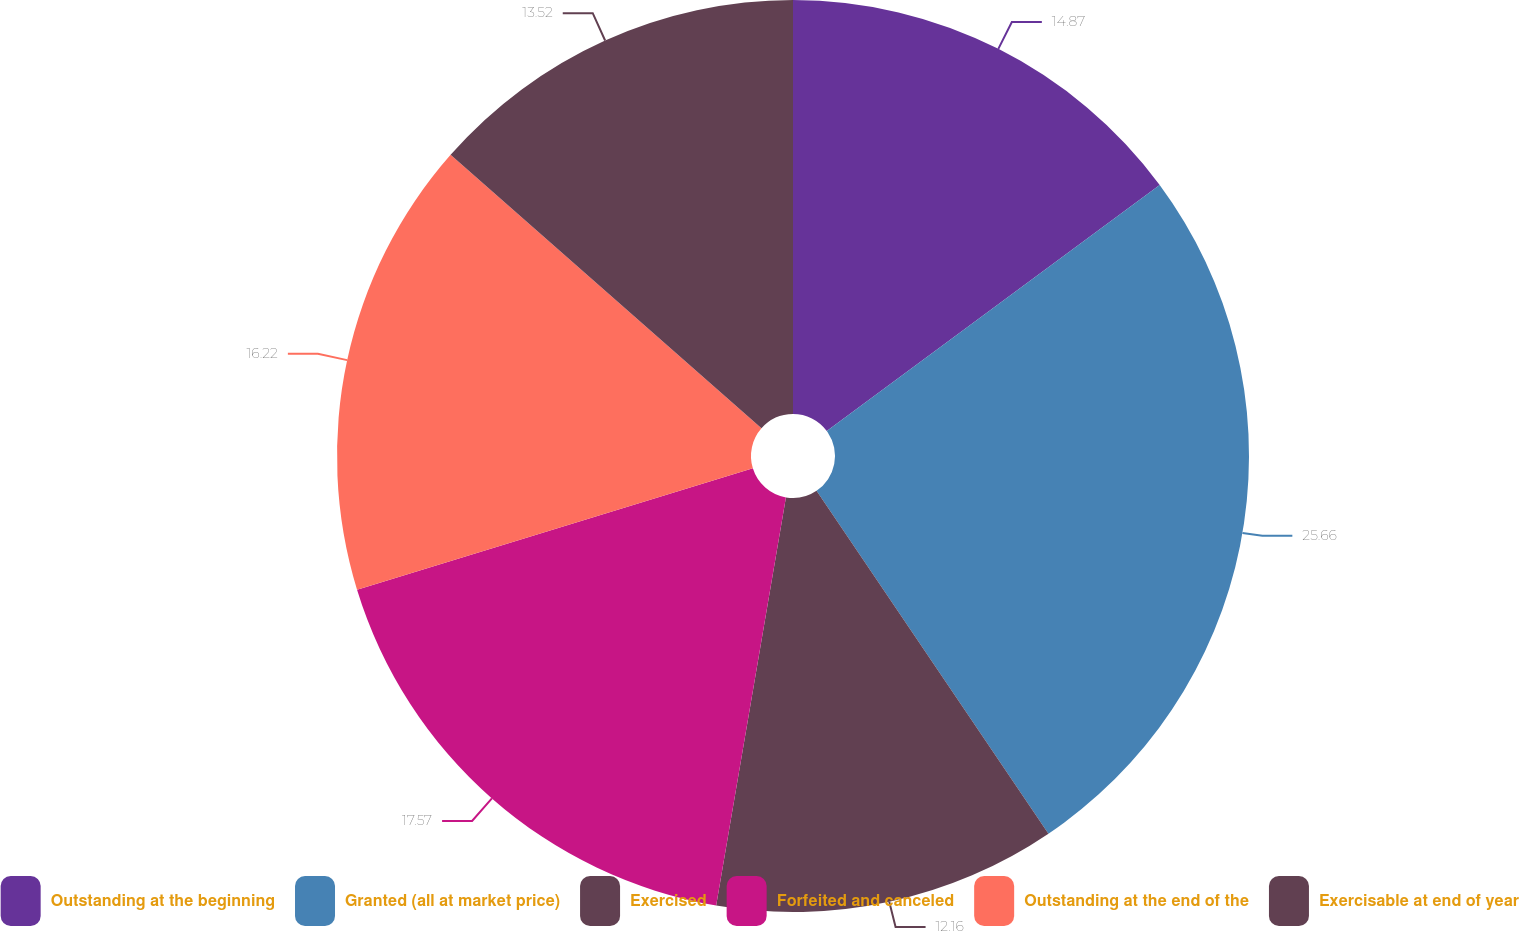<chart> <loc_0><loc_0><loc_500><loc_500><pie_chart><fcel>Outstanding at the beginning<fcel>Granted (all at market price)<fcel>Exercised<fcel>Forfeited and canceled<fcel>Outstanding at the end of the<fcel>Exercisable at end of year<nl><fcel>14.87%<fcel>25.67%<fcel>12.16%<fcel>17.57%<fcel>16.22%<fcel>13.52%<nl></chart> 